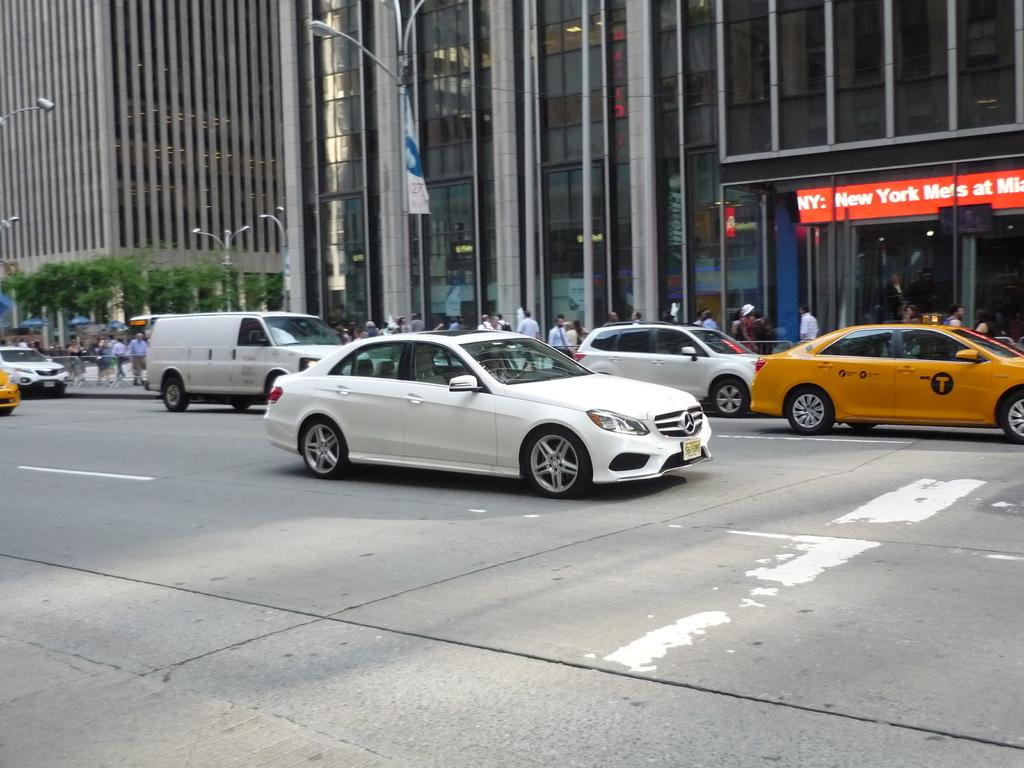Provide a one-sentence caption for the provided image. A red digital sign advertises that the New York Mets will be playing. 